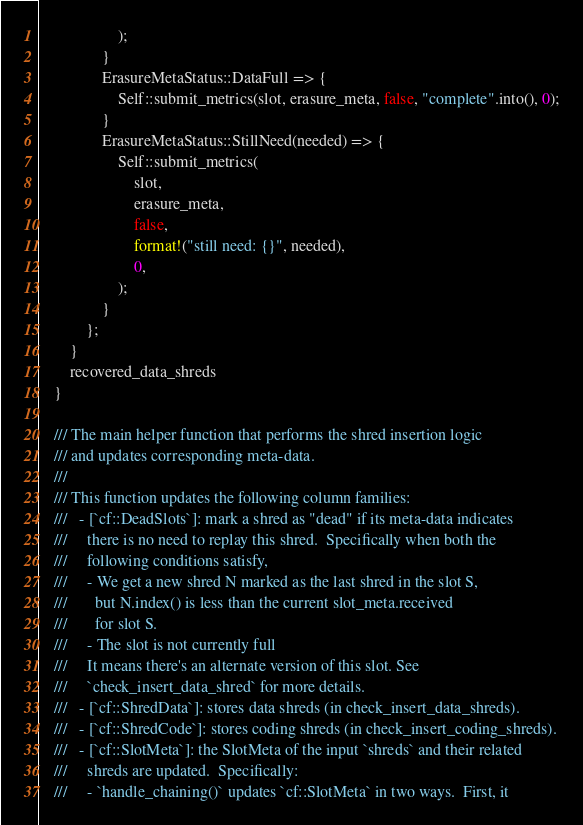<code> <loc_0><loc_0><loc_500><loc_500><_Rust_>                    );
                }
                ErasureMetaStatus::DataFull => {
                    Self::submit_metrics(slot, erasure_meta, false, "complete".into(), 0);
                }
                ErasureMetaStatus::StillNeed(needed) => {
                    Self::submit_metrics(
                        slot,
                        erasure_meta,
                        false,
                        format!("still need: {}", needed),
                        0,
                    );
                }
            };
        }
        recovered_data_shreds
    }

    /// The main helper function that performs the shred insertion logic
    /// and updates corresponding meta-data.
    ///
    /// This function updates the following column families:
    ///   - [`cf::DeadSlots`]: mark a shred as "dead" if its meta-data indicates
    ///     there is no need to replay this shred.  Specifically when both the
    ///     following conditions satisfy,
    ///     - We get a new shred N marked as the last shred in the slot S,
    ///       but N.index() is less than the current slot_meta.received
    ///       for slot S.
    ///     - The slot is not currently full
    ///     It means there's an alternate version of this slot. See
    ///     `check_insert_data_shred` for more details.
    ///   - [`cf::ShredData`]: stores data shreds (in check_insert_data_shreds).
    ///   - [`cf::ShredCode`]: stores coding shreds (in check_insert_coding_shreds).
    ///   - [`cf::SlotMeta`]: the SlotMeta of the input `shreds` and their related
    ///     shreds are updated.  Specifically:
    ///     - `handle_chaining()` updates `cf::SlotMeta` in two ways.  First, it</code> 